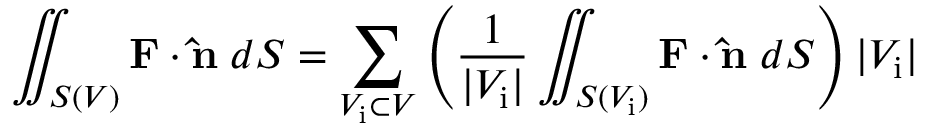Convert formula to latex. <formula><loc_0><loc_0><loc_500><loc_500>\iint _ { S ( V ) } F \cdot \hat { n } \, d S = \sum _ { V _ { i } \subset V } \left ( { \frac { 1 } { | V _ { i } | } } \iint _ { S ( V _ { i } ) } F \cdot \hat { n } \, d S \right ) | V _ { i } |</formula> 